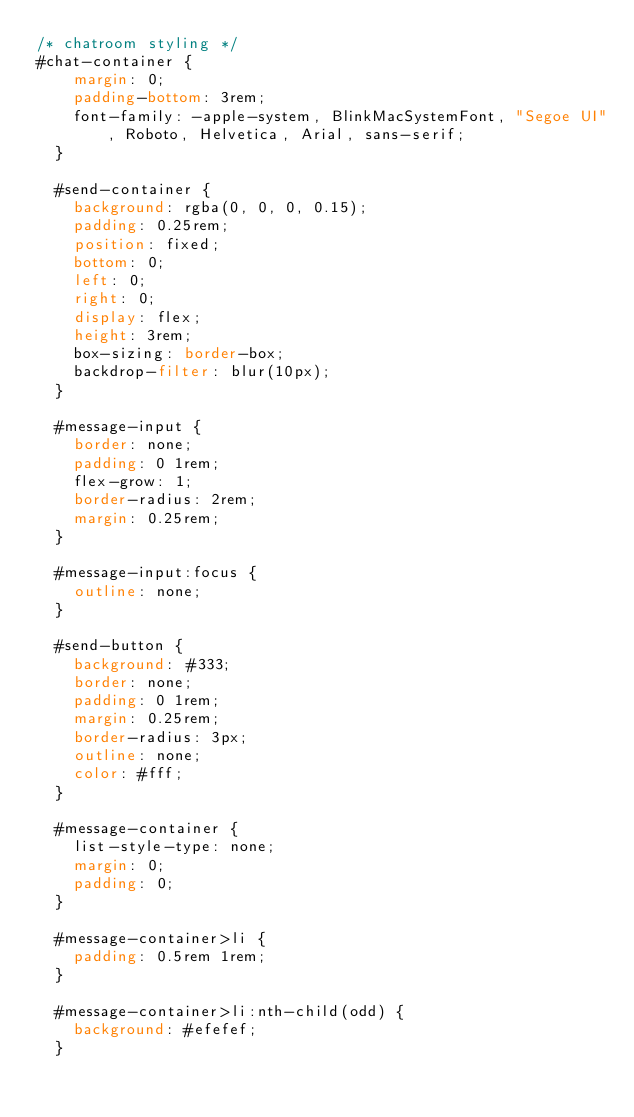Convert code to text. <code><loc_0><loc_0><loc_500><loc_500><_CSS_>/* chatroom styling */
#chat-container {
    margin: 0;
    padding-bottom: 3rem;
    font-family: -apple-system, BlinkMacSystemFont, "Segoe UI", Roboto, Helvetica, Arial, sans-serif;
  }
  
  #send-container {
    background: rgba(0, 0, 0, 0.15);
    padding: 0.25rem;
    position: fixed;
    bottom: 0;
    left: 0;
    right: 0;
    display: flex;
    height: 3rem;
    box-sizing: border-box;
    backdrop-filter: blur(10px);
  }
  
  #message-input {
    border: none;
    padding: 0 1rem;
    flex-grow: 1;
    border-radius: 2rem;
    margin: 0.25rem;
  }
  
  #message-input:focus {
    outline: none;
  }
  
  #send-button {
    background: #333;
    border: none;
    padding: 0 1rem;
    margin: 0.25rem;
    border-radius: 3px;
    outline: none;
    color: #fff;
  }
  
  #message-container {
    list-style-type: none;
    margin: 0;
    padding: 0;
  }
  
  #message-container>li {
    padding: 0.5rem 1rem;
  }
  
  #message-container>li:nth-child(odd) {
    background: #efefef;
  }</code> 